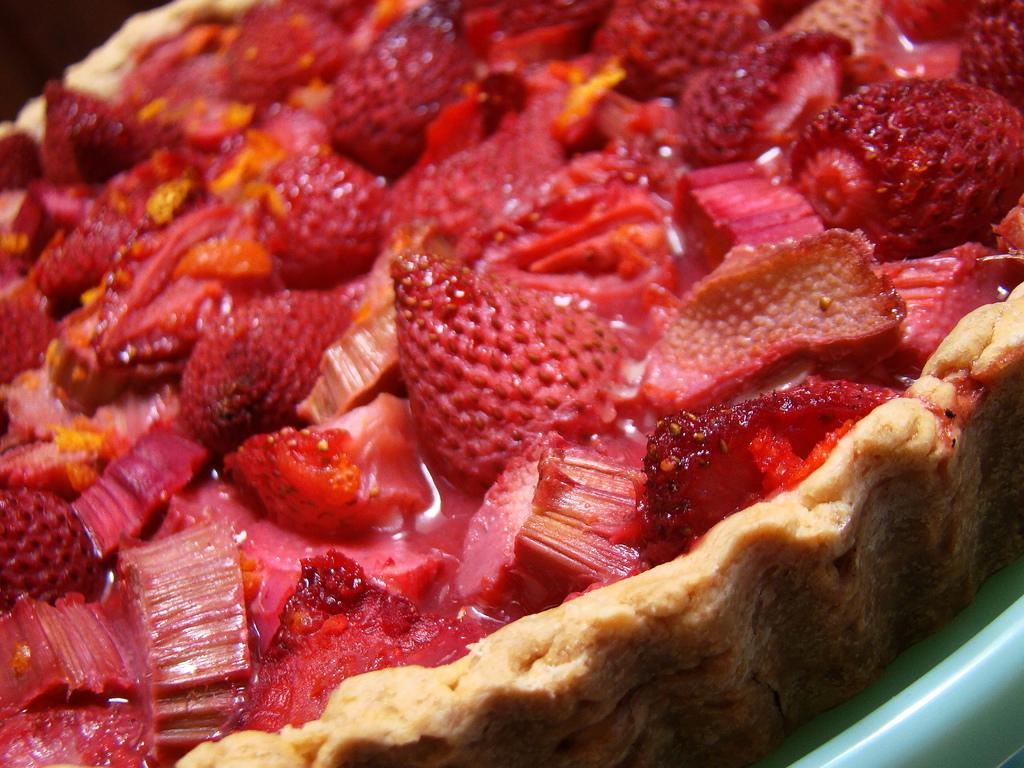What type of food item is visible in the image? There is a food item in the image. What is one of the main ingredients in the food item? The food item contains strawberries. Are there any other ingredients present in the food item? Yes, there are other ingredients present in the food item. Where is the throne located in the image? There is no throne present in the image. How many spoons are visible in the image? The provided facts do not mention the presence of spoons in the image. 